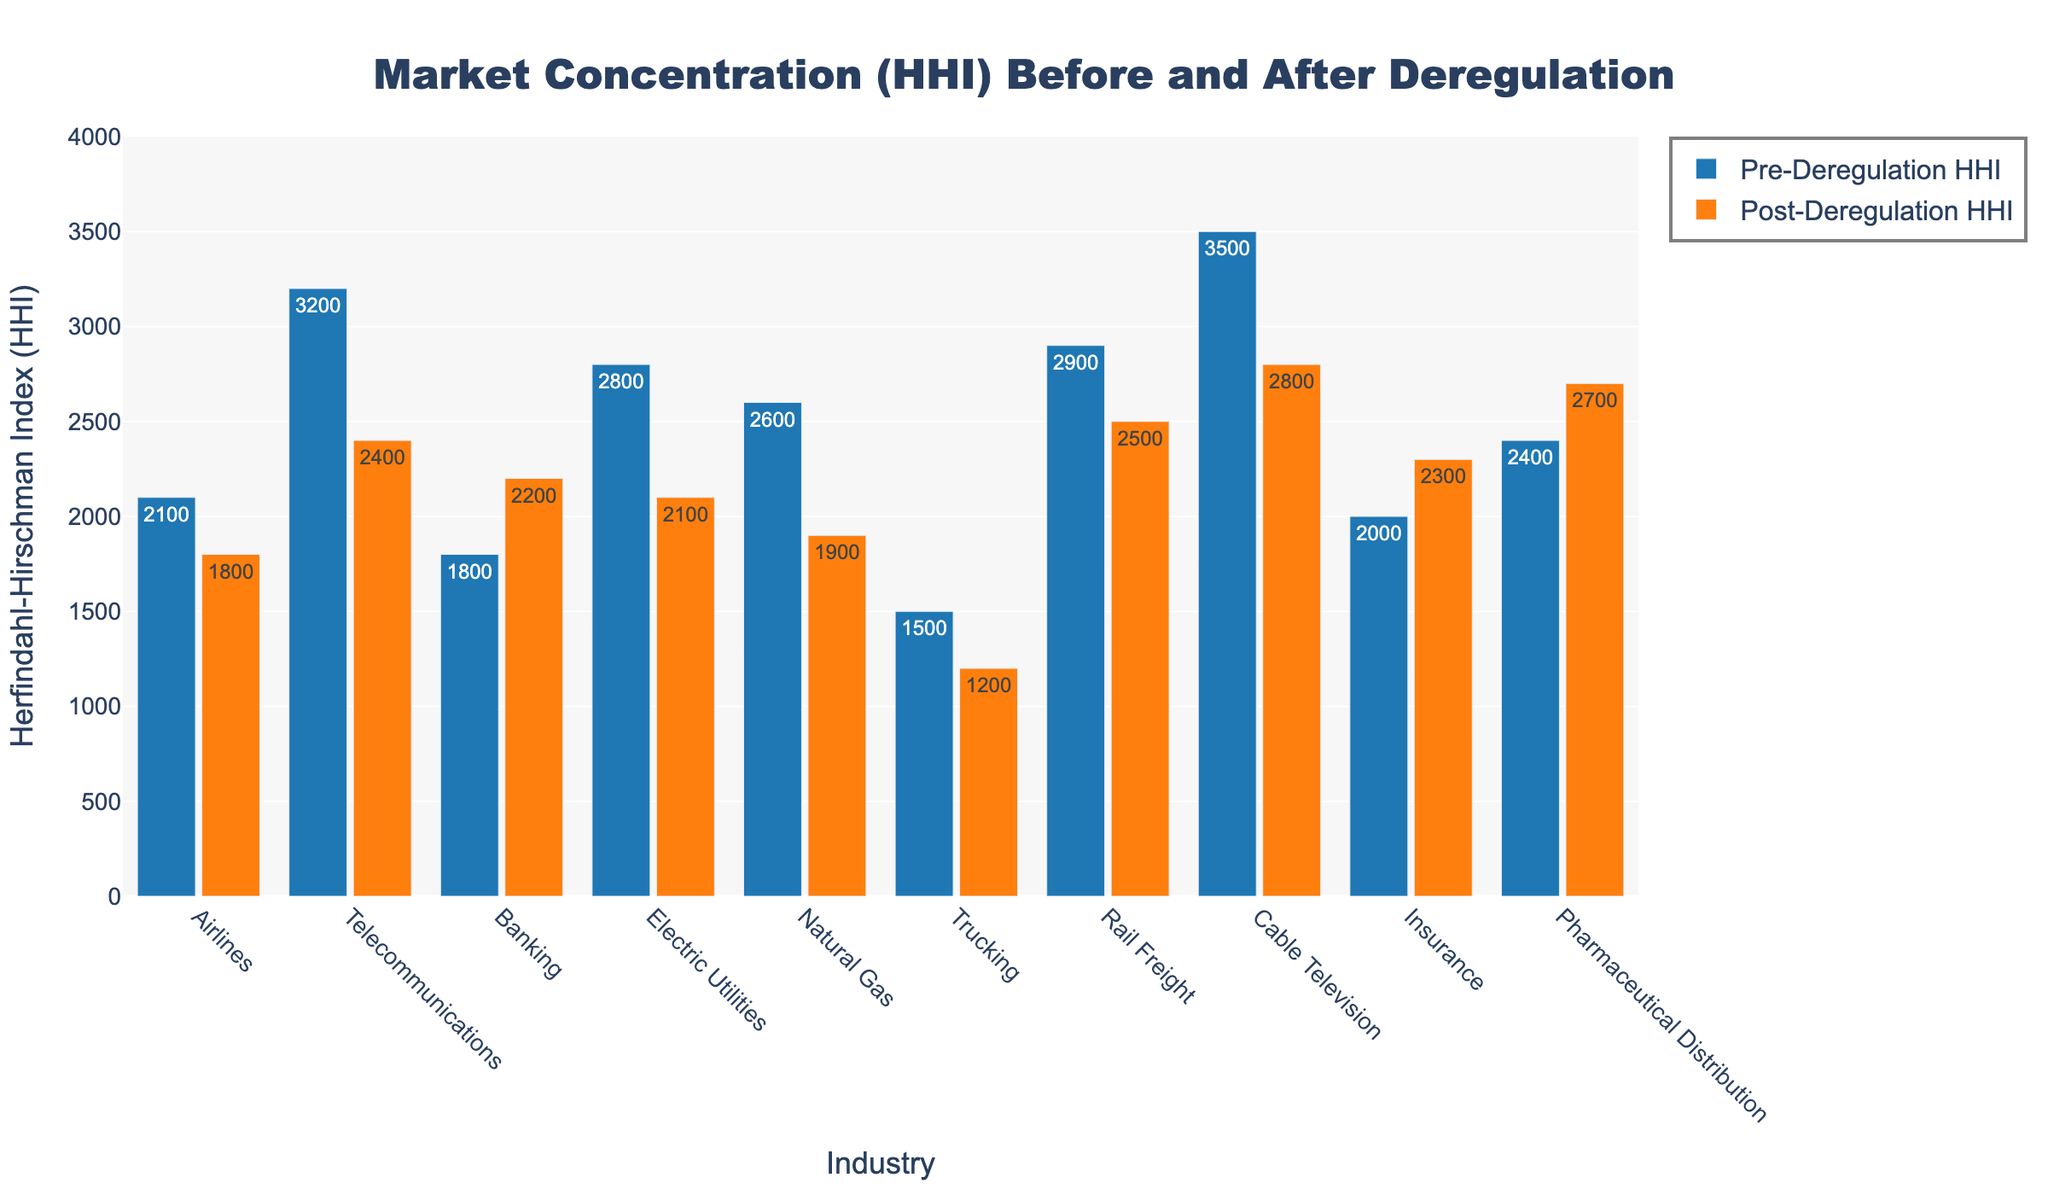What's the change in HHI for the Airlines industry after deregulation? The Pre-Deregulation HHI for Airlines is 2100, and the Post-Deregulation HHI is 1800. The change is calculated by subtracting the Post-Deregulation HHI from the Pre-Deregulation HHI: 2100 - 1800.
Answer: 300 Which industry experienced the highest reduction in HHI after deregulation? To determine this, subtract the Post-Deregulation HHI from the Pre-Deregulation HHI for each industry and find the industry with the maximum difference. For Cable Television, the difference is 3500 - 2800 = 700, which is the highest reduction among all industries.
Answer: Cable Television Are there any industries that saw an increase in HHI after deregulation? If yes, which ones? Compare Pre-Deregulation HHI and Post-Deregulation HHI values across industries. Both Banking and Pharmaceutical Distribution show an increase in HHI after deregulation.
Answer: Banking, Pharmaceutical Distribution What is the average Pre-Deregulation HHI across all industries? Sum the Pre-Deregulation HHI values for all industries: 2100 + 3200 + 1800 + 2800 + 2600 + 1500 + 2900 + 3500 + 2000 + 2400 = 27800. Divide the sum by the number of industries, which is 10: 27800 / 10.
Answer: 2780 Which industry had the highest Pre-Deregulation HHI, and what is its value? Look for the highest value in the Pre-Deregulation HHI column. The Cable Television industry has the highest Pre-Deregulation HHI with a value of 3500.
Answer: Cable Television, 3500 What is the total reduction in HHI for the Electric Utilities and Telecommunications industries combined? For Electric Utilities, the change is 2800 - 2100 = 700. For Telecommunications, the change is 3200 - 2400 = 800. The sum of reductions is 700 + 800.
Answer: 1500 Compare the Pre-Deregulation and Post-Deregulation HHI for the Trucking industry. Which one is greater and by how much? The Pre-Deregulation HHI for Trucking is 1500 and Post-Deregulation is 1200. The Pre-Deregulation HHI is greater by 1500 - 1200.
Answer: Pre-Deregulation by 300 What is the sum of the Post-Deregulation HHIs for the Banking and Insurance industries? Add the Post-Deregulation HHI values for Banking and Insurance: 2200 + 2300.
Answer: 4500 Which industry shows the least difference between Pre-Deregulation and Post-Deregulation HHI values? Compute the differences and find the minimum. For Airlines: 300, Telecommunications: 800, Banking: -400, Electric Utilities: 700, Natural Gas: 700, Trucking: 300, Rail Freight: 400, Cable Television: 700, Insurance: -300, Pharmaceutical Distribution: -300. The smallest absolute difference is for Airlines and Trucking: 300.
Answer: Airlines, Trucking How many industries have a Post-Deregulation HHI less than 2000? Count the industries where the Post-Deregulation HHI is below 2000: Airlines (1800), Telecommunications (2400), Banking (2200), Electric Utilities (2100), Natural Gas (1900), Trucking (1200), Rail Freight (2500), Cable Television (2800), Insurance (2300), Pharmaceutical Distribution (2700). Only Airlines, Natural Gas, and Trucking have HHI less than 2000.
Answer: 3 